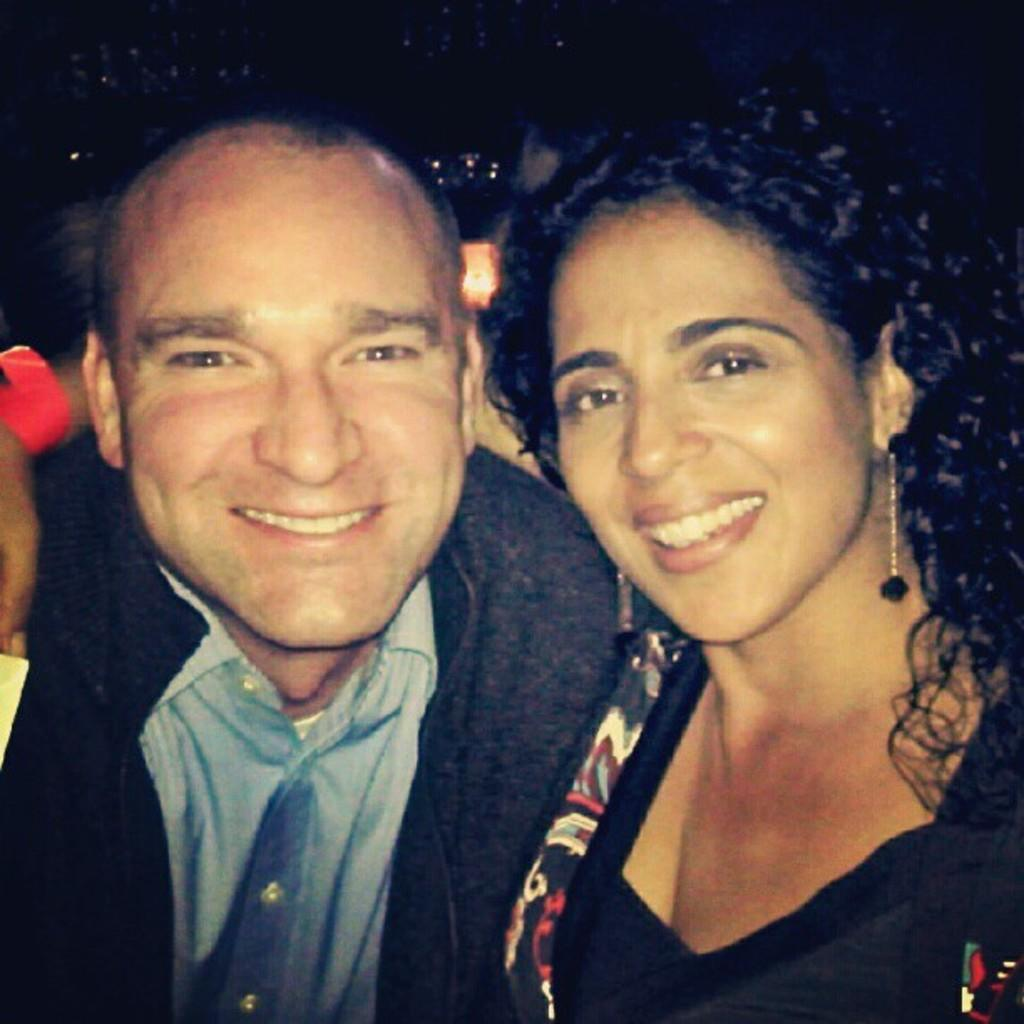How many people are in the image? There are two people in the image. What expression do the people have? The people are smiling. Can you describe the background of the image? The background of the image is dark. What type of weather can be seen in the image? There is no weather visible in the image, as it is focused on the two people and their expressions. 